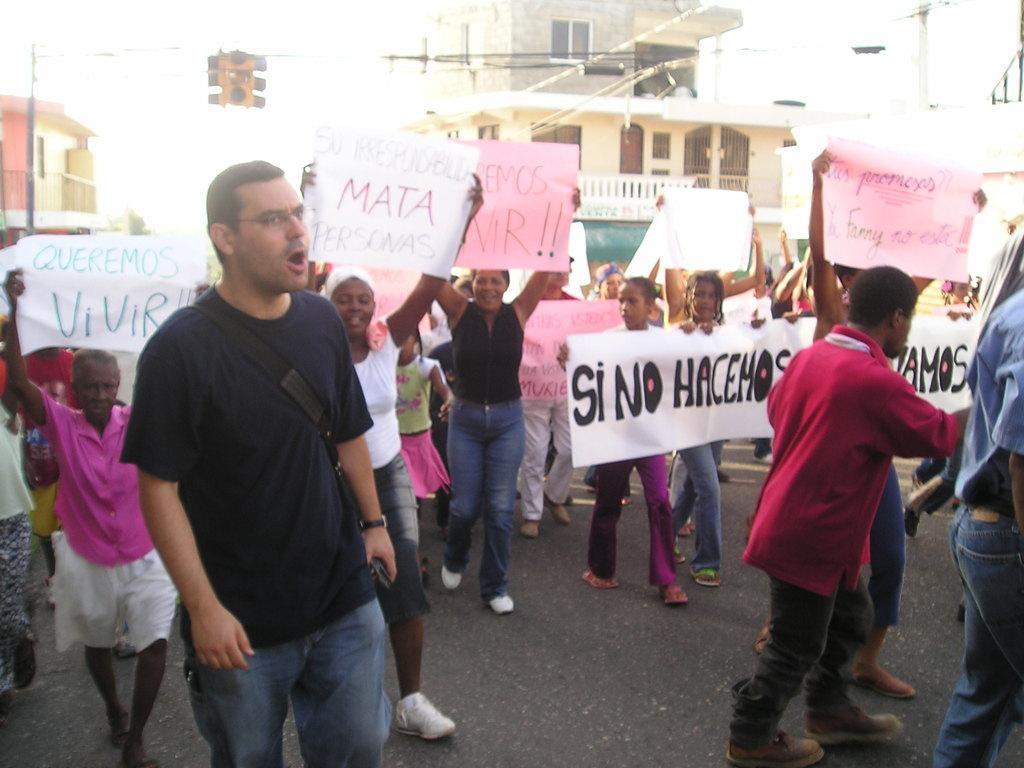How would you summarize this image in a sentence or two? In this image I can see number of persons are standing on the ground holding few boards in their hands which are white and pink in color. In the background I can see few buildings and few poles. 